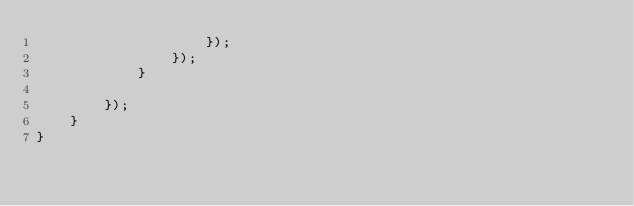Convert code to text. <code><loc_0><loc_0><loc_500><loc_500><_JavaScript_>                    });
                });
            }

        });
    }
}
</code> 